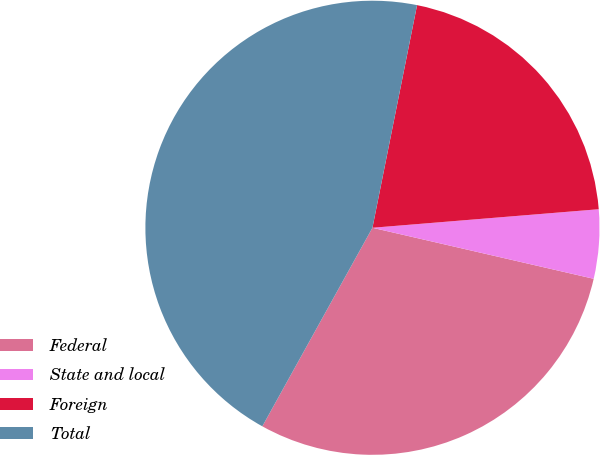Convert chart to OTSL. <chart><loc_0><loc_0><loc_500><loc_500><pie_chart><fcel>Federal<fcel>State and local<fcel>Foreign<fcel>Total<nl><fcel>29.45%<fcel>4.91%<fcel>20.55%<fcel>45.09%<nl></chart> 